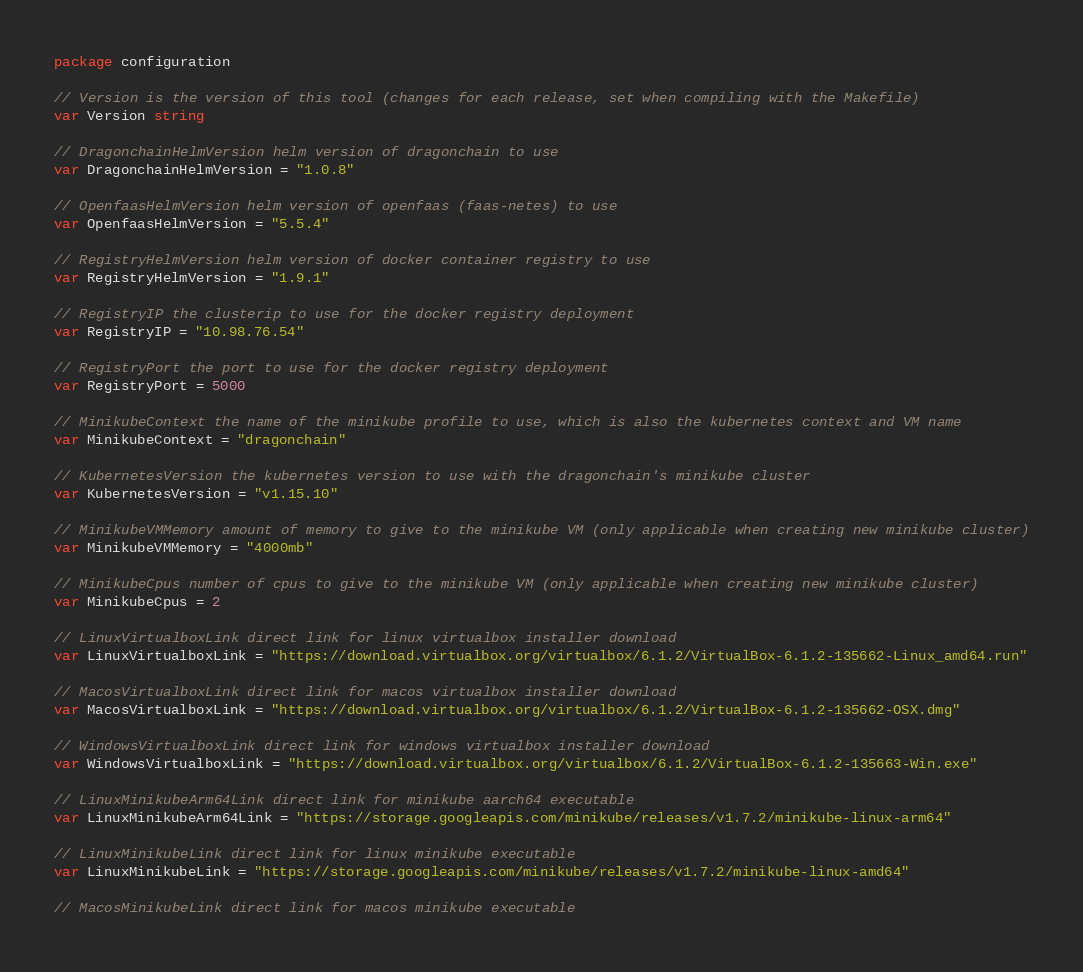Convert code to text. <code><loc_0><loc_0><loc_500><loc_500><_Go_>package configuration

// Version is the version of this tool (changes for each release, set when compiling with the Makefile)
var Version string

// DragonchainHelmVersion helm version of dragonchain to use
var DragonchainHelmVersion = "1.0.8"

// OpenfaasHelmVersion helm version of openfaas (faas-netes) to use
var OpenfaasHelmVersion = "5.5.4"

// RegistryHelmVersion helm version of docker container registry to use
var RegistryHelmVersion = "1.9.1"

// RegistryIP the clusterip to use for the docker registry deployment
var RegistryIP = "10.98.76.54"

// RegistryPort the port to use for the docker registry deployment
var RegistryPort = 5000

// MinikubeContext the name of the minikube profile to use, which is also the kubernetes context and VM name
var MinikubeContext = "dragonchain"

// KubernetesVersion the kubernetes version to use with the dragonchain's minikube cluster
var KubernetesVersion = "v1.15.10"

// MinikubeVMMemory amount of memory to give to the minikube VM (only applicable when creating new minikube cluster)
var MinikubeVMMemory = "4000mb"

// MinikubeCpus number of cpus to give to the minikube VM (only applicable when creating new minikube cluster)
var MinikubeCpus = 2

// LinuxVirtualboxLink direct link for linux virtualbox installer download
var LinuxVirtualboxLink = "https://download.virtualbox.org/virtualbox/6.1.2/VirtualBox-6.1.2-135662-Linux_amd64.run"

// MacosVirtualboxLink direct link for macos virtualbox installer download
var MacosVirtualboxLink = "https://download.virtualbox.org/virtualbox/6.1.2/VirtualBox-6.1.2-135662-OSX.dmg"

// WindowsVirtualboxLink direct link for windows virtualbox installer download
var WindowsVirtualboxLink = "https://download.virtualbox.org/virtualbox/6.1.2/VirtualBox-6.1.2-135663-Win.exe"

// LinuxMinikubeArm64Link direct link for minikube aarch64 executable
var LinuxMinikubeArm64Link = "https://storage.googleapis.com/minikube/releases/v1.7.2/minikube-linux-arm64"

// LinuxMinikubeLink direct link for linux minikube executable
var LinuxMinikubeLink = "https://storage.googleapis.com/minikube/releases/v1.7.2/minikube-linux-amd64"

// MacosMinikubeLink direct link for macos minikube executable</code> 